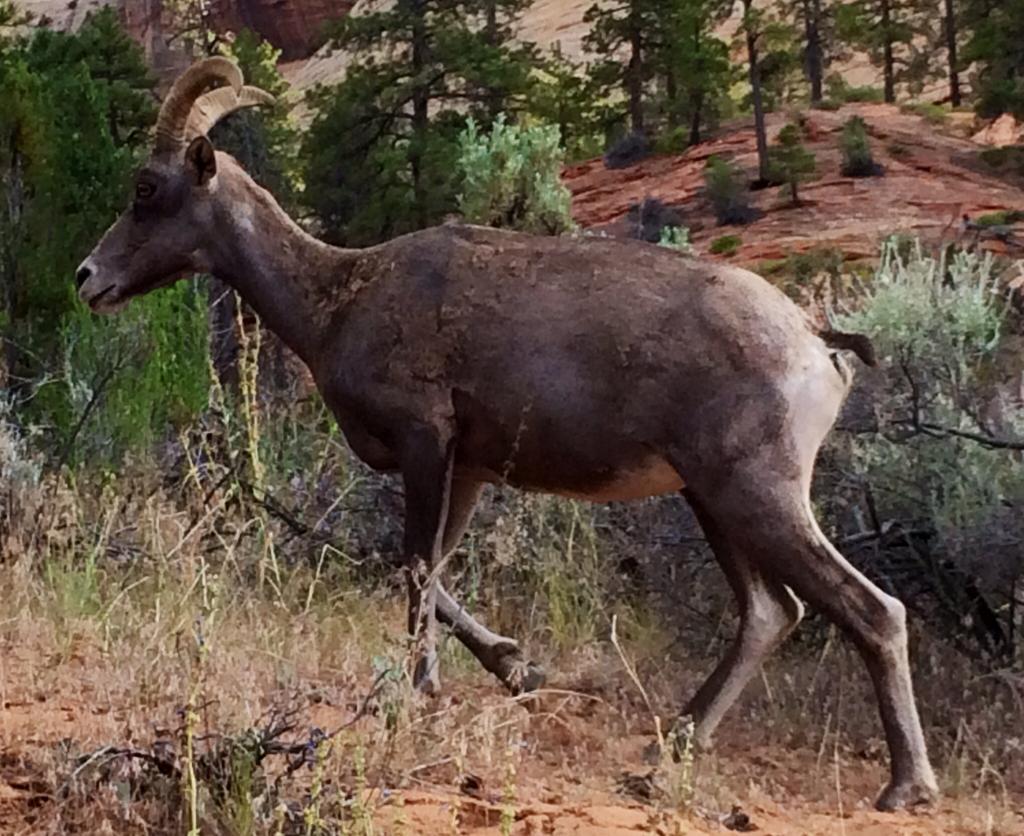Could you give a brief overview of what you see in this image? This image is a painting where we can see an animal is walking on the ground. In the background, we can see trees and stone hills. 